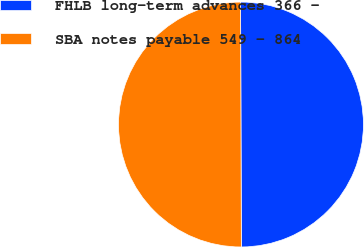Convert chart. <chart><loc_0><loc_0><loc_500><loc_500><pie_chart><fcel>FHLB long-term advances 366 -<fcel>SBA notes payable 549 - 864<nl><fcel>50.0%<fcel>50.0%<nl></chart> 